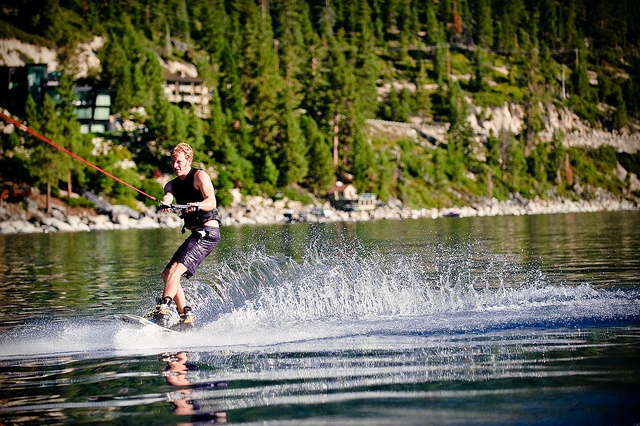Describe the objects in this image and their specific colors. I can see people in black, white, gray, and lightpink tones and surfboard in black, lightgray, darkgray, and gray tones in this image. 